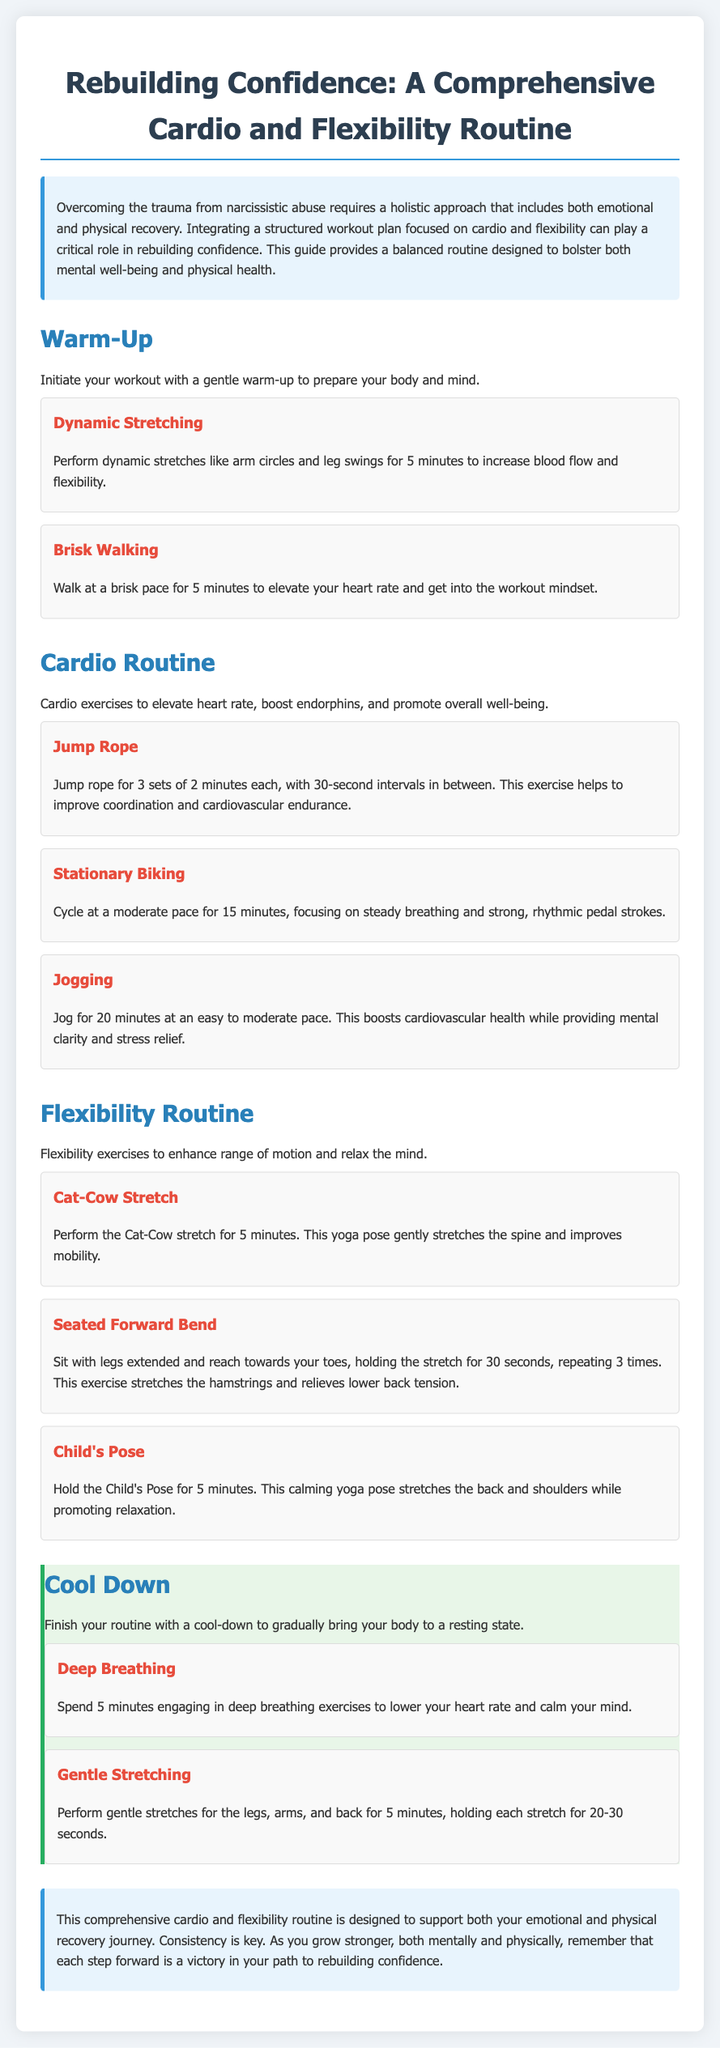What is the purpose of the workout plan? The introduction states that the workout plan aims to support emotional and physical recovery from narcissistic abuse.
Answer: Emotional and physical recovery How long should one do Jump Rope? The cardio section specifies to jump rope for 3 sets of 2 minutes each.
Answer: 3 sets of 2 minutes What exercise is suggested for the cool-down? The cool-down section includes deep breathing exercises to lower heart rate.
Answer: Deep breathing What is the first exercise in the Warm-Up section? The Warm-Up section lists dynamic stretching as the first exercise.
Answer: Dynamic Stretching How long should you hold the Child's Pose? The flexibility routine indicates holding the Child's Pose for 5 minutes.
Answer: 5 minutes What does the Seated Forward Bend target? The description mentions that it stretches the hamstrings and relieves lower back tension.
Answer: Hamstrings and lower back What should be the focus during stationary biking? The instructional content advises focusing on steady breathing and strong, rhythmic pedal strokes.
Answer: Steady breathing and strong, rhythmic pedal strokes What message is conveyed in the conclusion? The conclusion emphasizes consistency as key to rebuilding confidence through exercise.
Answer: Consistency is key What type of routine does this workout plan provide? The introduction states that it is a comprehensive cardio and flexibility routine.
Answer: Comprehensive cardio and flexibility routine 